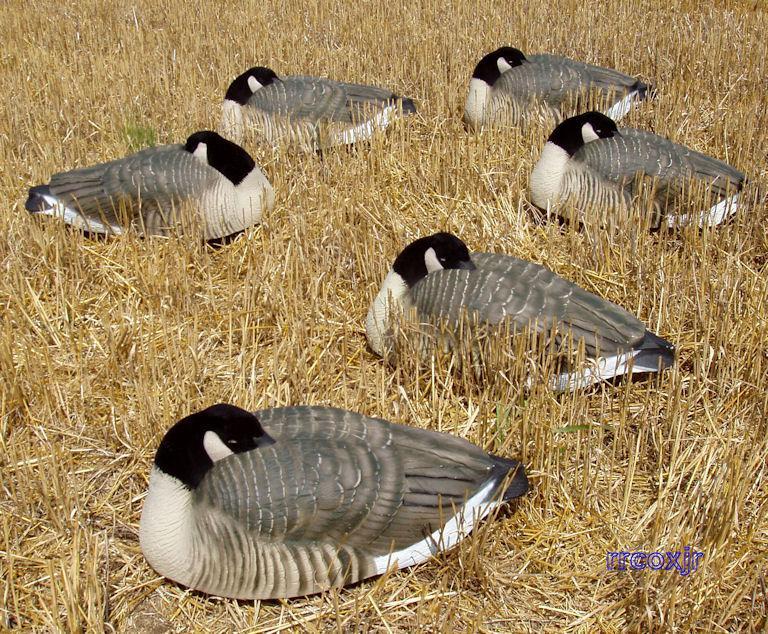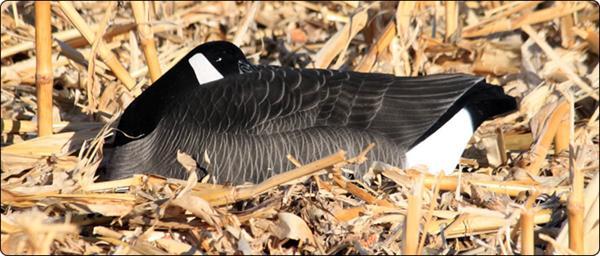The first image is the image on the left, the second image is the image on the right. For the images displayed, is the sentence "The right image features a duck decoy on shredded material, and no image contains more than six decoys in the foreground." factually correct? Answer yes or no. Yes. The first image is the image on the left, the second image is the image on the right. Evaluate the accuracy of this statement regarding the images: "The birds in at least one of the images are near a tree surrounded area.". Is it true? Answer yes or no. No. 